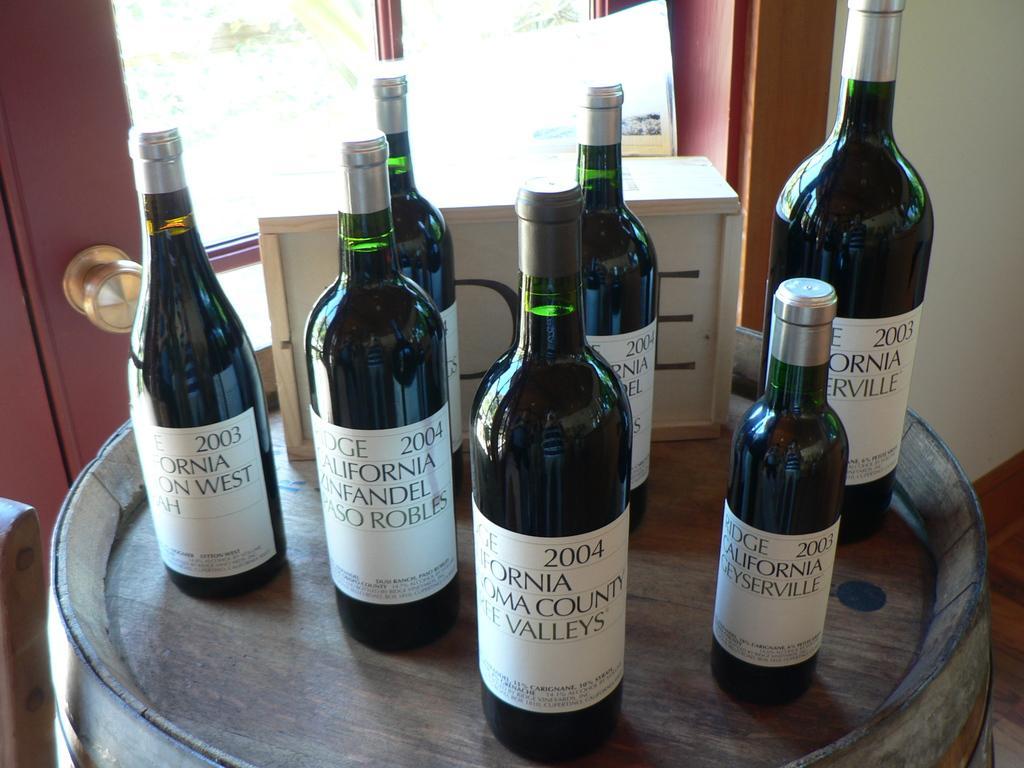Can you describe this image briefly? In this picture there are the wine bottles. The wine bottles is on the barrel. Backside of this bottle there is a door. 